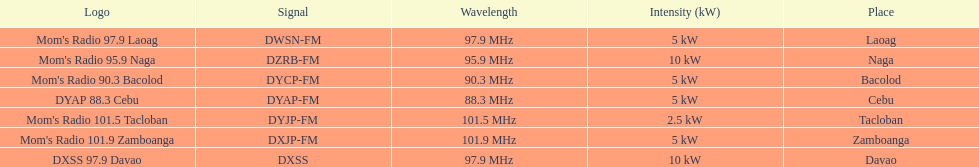How many kw was the radio in davao? 10 kW. 